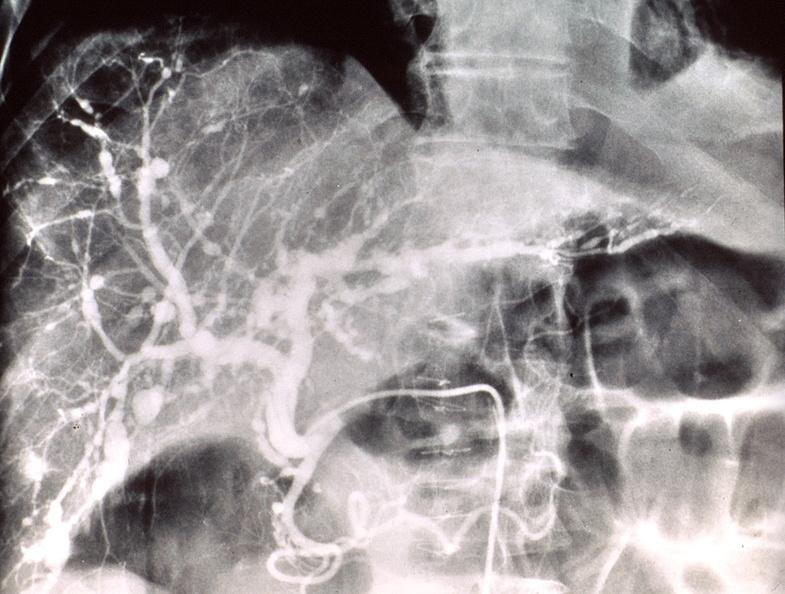s blood present?
Answer the question using a single word or phrase. No 